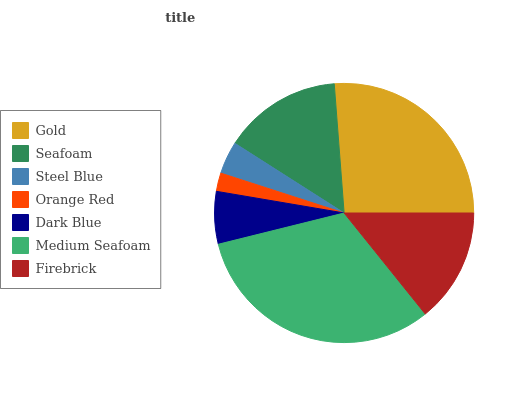Is Orange Red the minimum?
Answer yes or no. Yes. Is Medium Seafoam the maximum?
Answer yes or no. Yes. Is Seafoam the minimum?
Answer yes or no. No. Is Seafoam the maximum?
Answer yes or no. No. Is Gold greater than Seafoam?
Answer yes or no. Yes. Is Seafoam less than Gold?
Answer yes or no. Yes. Is Seafoam greater than Gold?
Answer yes or no. No. Is Gold less than Seafoam?
Answer yes or no. No. Is Firebrick the high median?
Answer yes or no. Yes. Is Firebrick the low median?
Answer yes or no. Yes. Is Orange Red the high median?
Answer yes or no. No. Is Orange Red the low median?
Answer yes or no. No. 